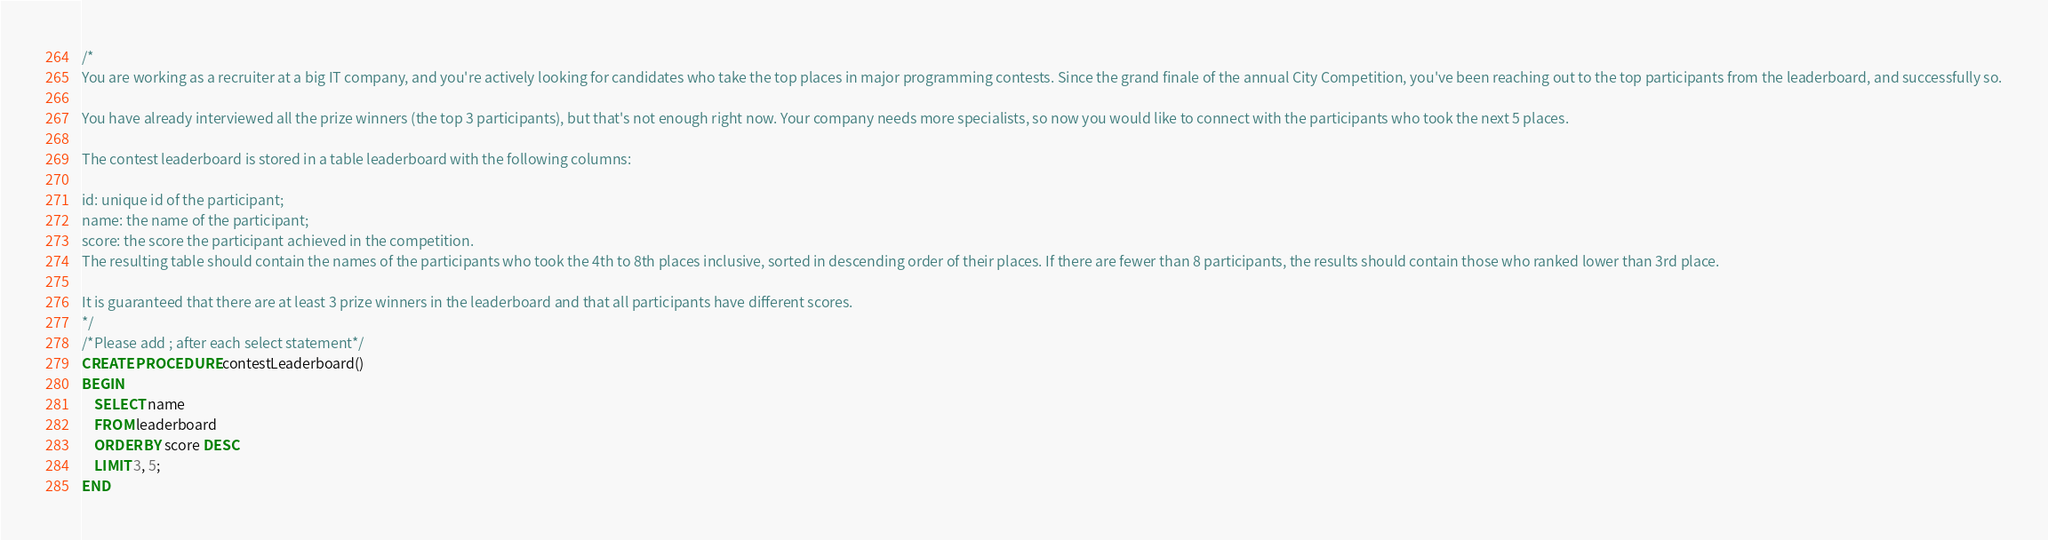<code> <loc_0><loc_0><loc_500><loc_500><_SQL_>/*
You are working as a recruiter at a big IT company, and you're actively looking for candidates who take the top places in major programming contests. Since the grand finale of the annual City Competition, you've been reaching out to the top participants from the leaderboard, and successfully so.

You have already interviewed all the prize winners (the top 3 participants), but that's not enough right now. Your company needs more specialists, so now you would like to connect with the participants who took the next 5 places.

The contest leaderboard is stored in a table leaderboard with the following columns:

id: unique id of the participant;
name: the name of the participant;
score: the score the participant achieved in the competition.
The resulting table should contain the names of the participants who took the 4th to 8th places inclusive, sorted in descending order of their places. If there are fewer than 8 participants, the results should contain those who ranked lower than 3rd place.

It is guaranteed that there are at least 3 prize winners in the leaderboard and that all participants have different scores.
*/
/*Please add ; after each select statement*/
CREATE PROCEDURE contestLeaderboard()
BEGIN
	SELECT name
    FROM leaderboard
    ORDER BY score DESC
    LIMIT 3, 5;
END</code> 